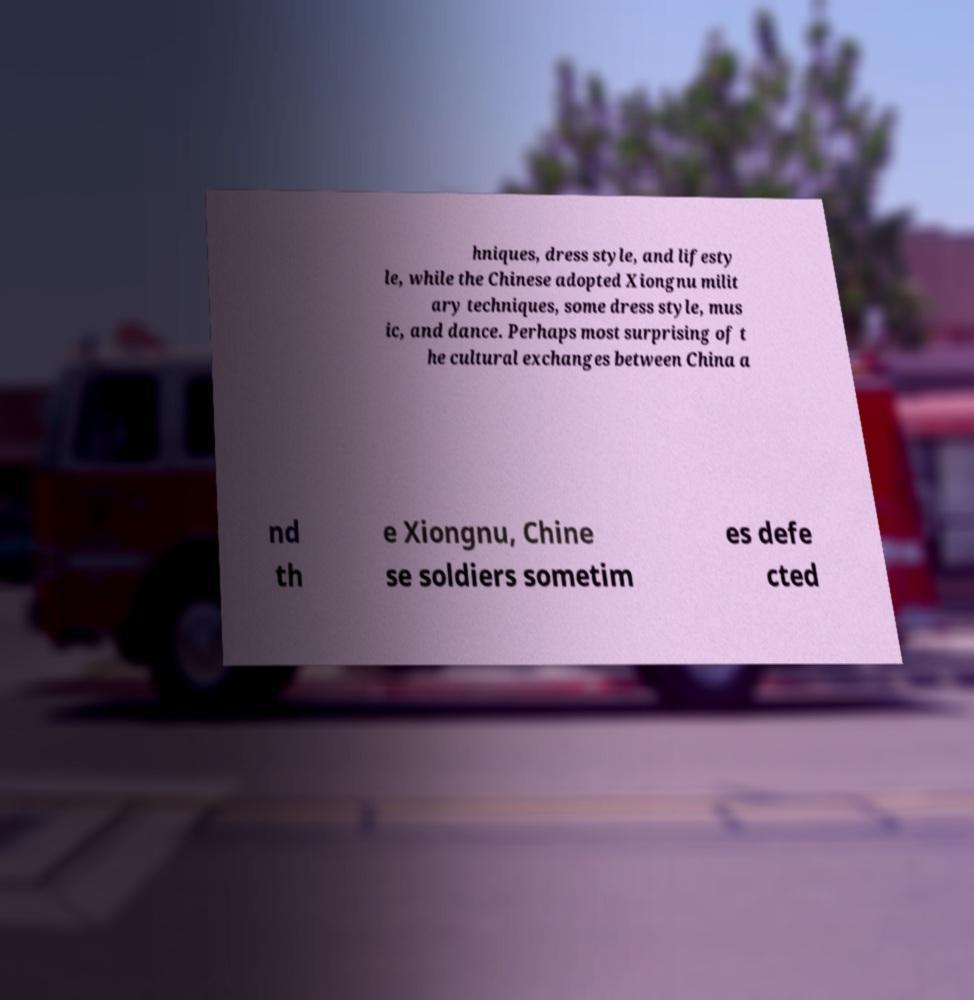What messages or text are displayed in this image? I need them in a readable, typed format. hniques, dress style, and lifesty le, while the Chinese adopted Xiongnu milit ary techniques, some dress style, mus ic, and dance. Perhaps most surprising of t he cultural exchanges between China a nd th e Xiongnu, Chine se soldiers sometim es defe cted 